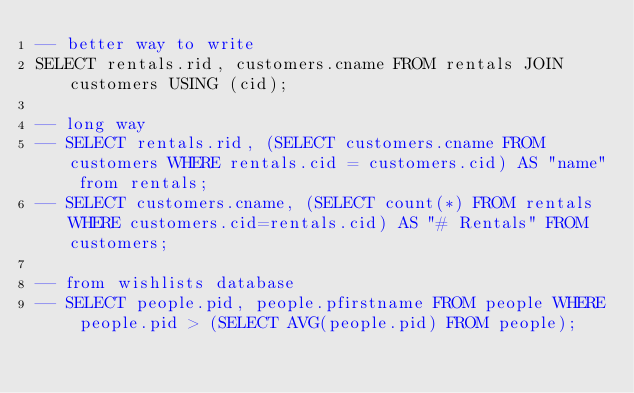<code> <loc_0><loc_0><loc_500><loc_500><_SQL_>-- better way to write
SELECT rentals.rid, customers.cname FROM rentals JOIN customers USING (cid);

-- long way
-- SELECT rentals.rid, (SELECT customers.cname FROM customers WHERE rentals.cid = customers.cid) AS "name" from rentals;
-- SELECT customers.cname, (SELECT count(*) FROM rentals WHERE customers.cid=rentals.cid) AS "# Rentals" FROM customers;

-- from wishlists database
-- SELECT people.pid, people.pfirstname FROM people WHERE people.pid > (SELECT AVG(people.pid) FROM people);</code> 